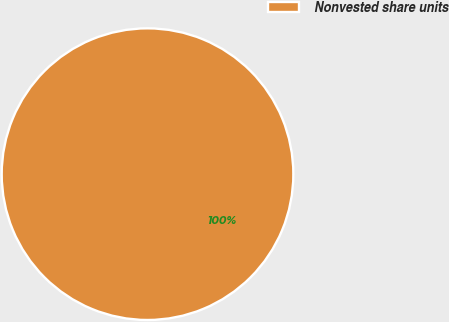Convert chart. <chart><loc_0><loc_0><loc_500><loc_500><pie_chart><fcel>Nonvested share units<nl><fcel>100.0%<nl></chart> 